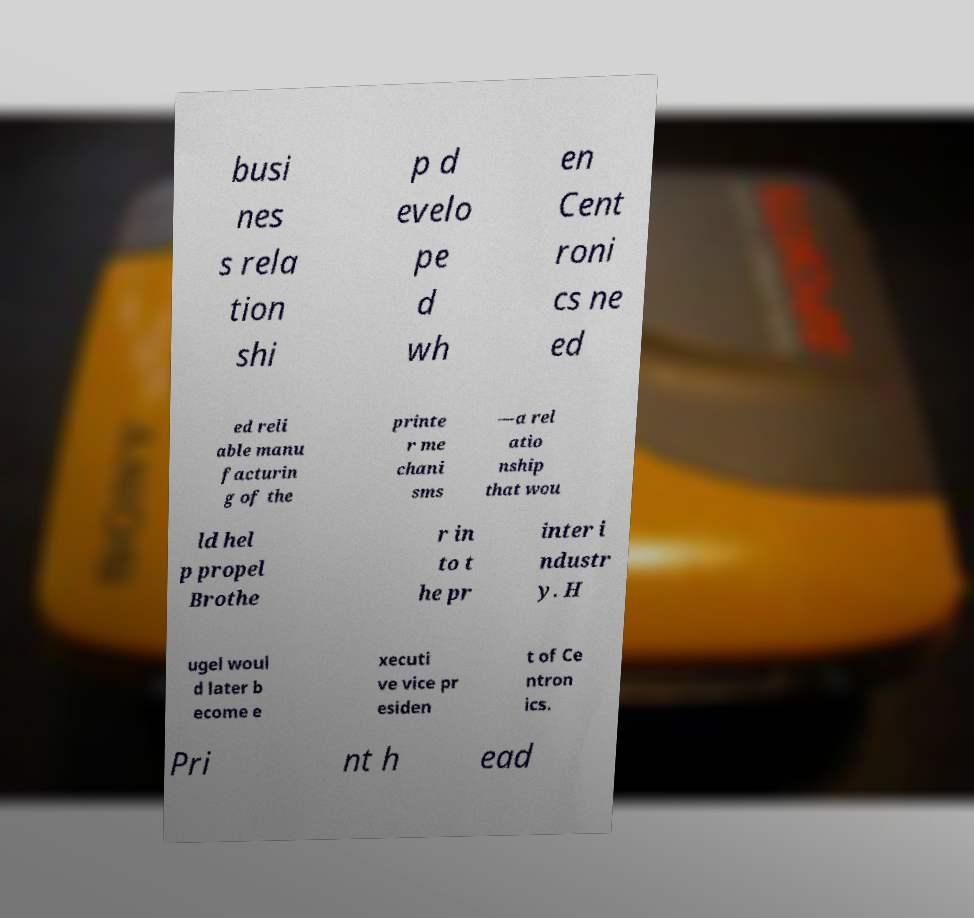Could you extract and type out the text from this image? busi nes s rela tion shi p d evelo pe d wh en Cent roni cs ne ed ed reli able manu facturin g of the printe r me chani sms —a rel atio nship that wou ld hel p propel Brothe r in to t he pr inter i ndustr y. H ugel woul d later b ecome e xecuti ve vice pr esiden t of Ce ntron ics. Pri nt h ead 